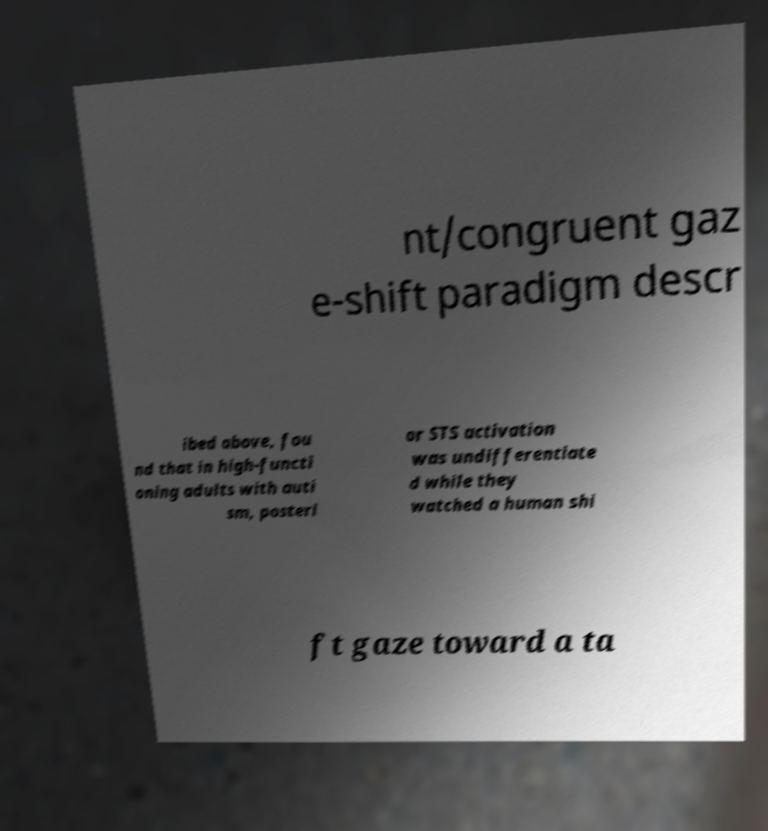For documentation purposes, I need the text within this image transcribed. Could you provide that? nt/congruent gaz e-shift paradigm descr ibed above, fou nd that in high-functi oning adults with auti sm, posteri or STS activation was undifferentiate d while they watched a human shi ft gaze toward a ta 